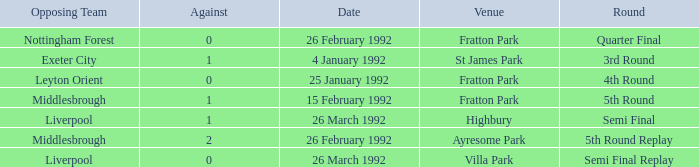What was the round for Villa Park? Semi Final Replay. 